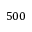Convert formula to latex. <formula><loc_0><loc_0><loc_500><loc_500>5 0 0</formula> 